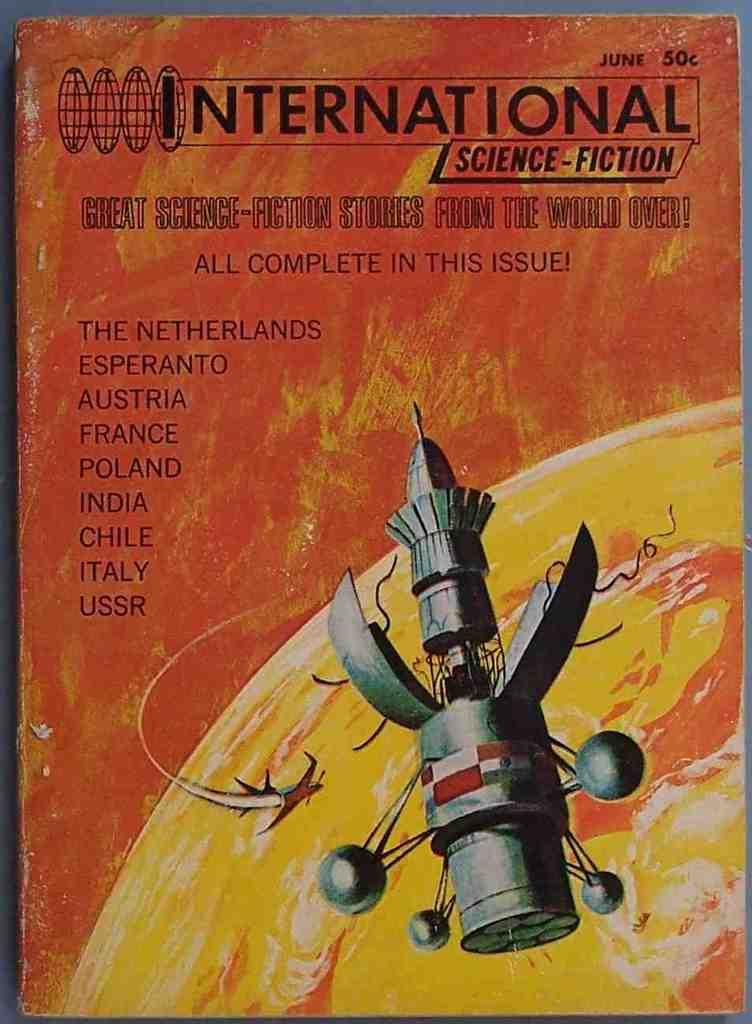What country is listed first in the list?
Make the answer very short. The netherlands. What is the firt letter of the title?
Your answer should be very brief. I. 